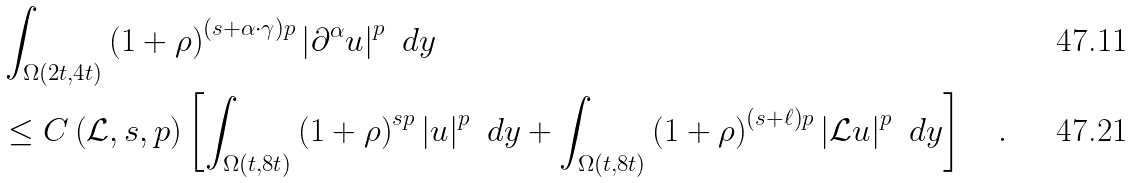Convert formula to latex. <formula><loc_0><loc_0><loc_500><loc_500>& \int _ { \Omega ( 2 t , 4 t ) } \left ( 1 + \rho \right ) ^ { \left ( s + \alpha \cdot \gamma \right ) p } \left | \partial ^ { \alpha } u \right | ^ { p } \ d y \\ & \leq C \left ( \mathcal { L } , s , p \right ) \left [ \int _ { \Omega ( t , 8 t ) } \left ( 1 + \rho \right ) ^ { s p } \left | u \right | ^ { p } \ d y + \int _ { \Omega ( t , 8 t ) } \left ( 1 + \rho \right ) ^ { \left ( s + \ell \right ) p } \left | \mathcal { L } u \right | ^ { p } \ d y \right ] \quad .</formula> 